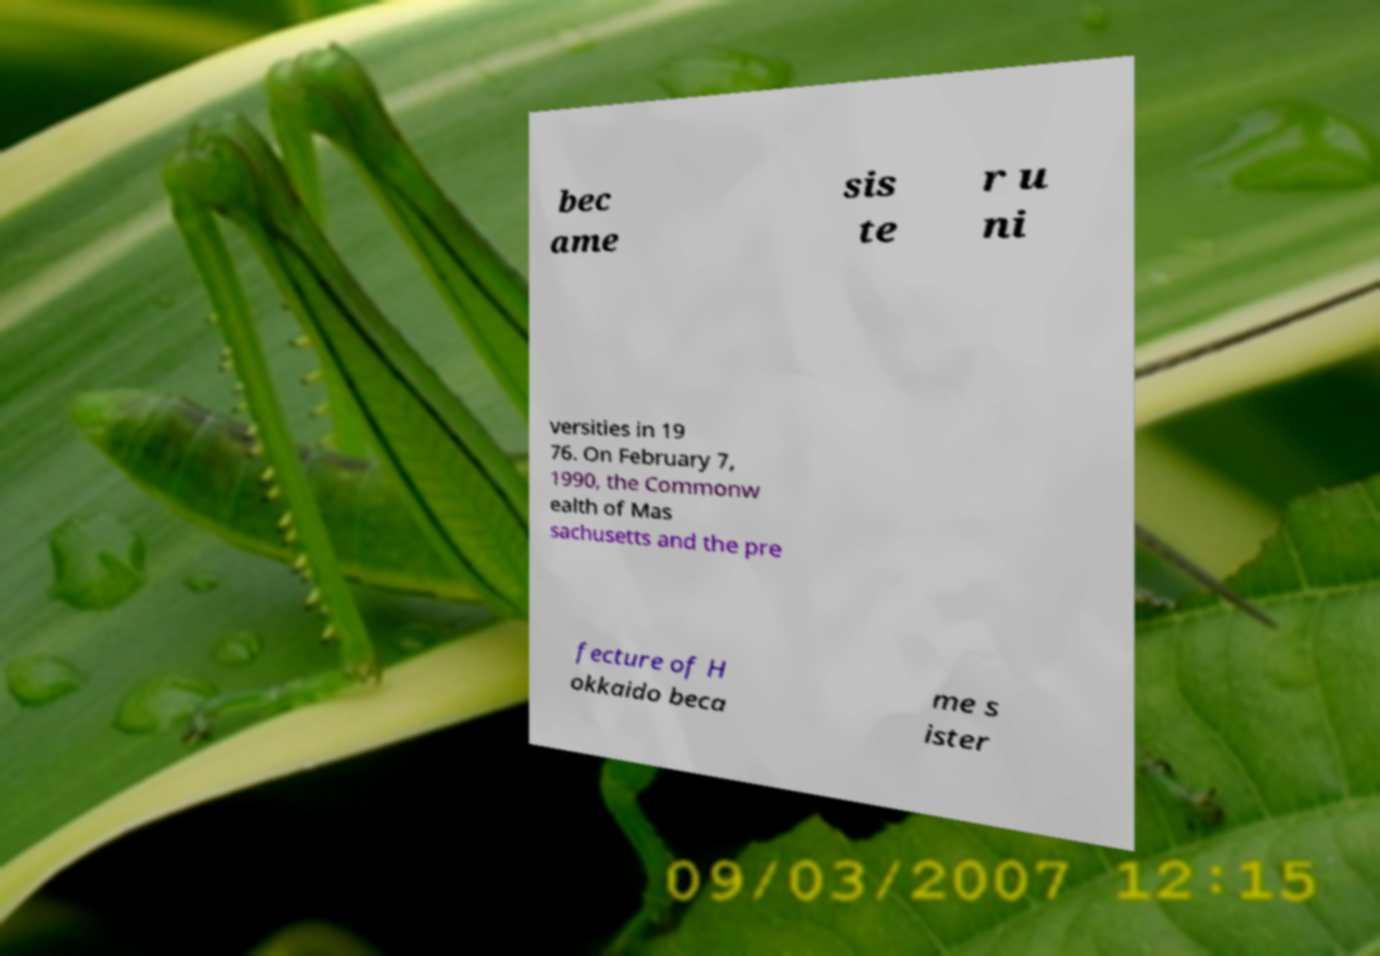What messages or text are displayed in this image? I need them in a readable, typed format. bec ame sis te r u ni versities in 19 76. On February 7, 1990, the Commonw ealth of Mas sachusetts and the pre fecture of H okkaido beca me s ister 